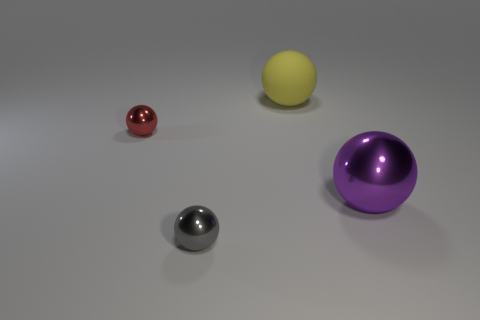Subtract all red spheres. How many spheres are left? 3 Subtract all gray spheres. How many spheres are left? 3 Subtract 1 balls. How many balls are left? 3 Add 1 red metal spheres. How many objects exist? 5 Subtract all red spheres. Subtract all cyan cylinders. How many spheres are left? 3 Subtract 1 gray balls. How many objects are left? 3 Subtract all purple objects. Subtract all big metal spheres. How many objects are left? 2 Add 3 large purple balls. How many large purple balls are left? 4 Add 2 small yellow shiny objects. How many small yellow shiny objects exist? 2 